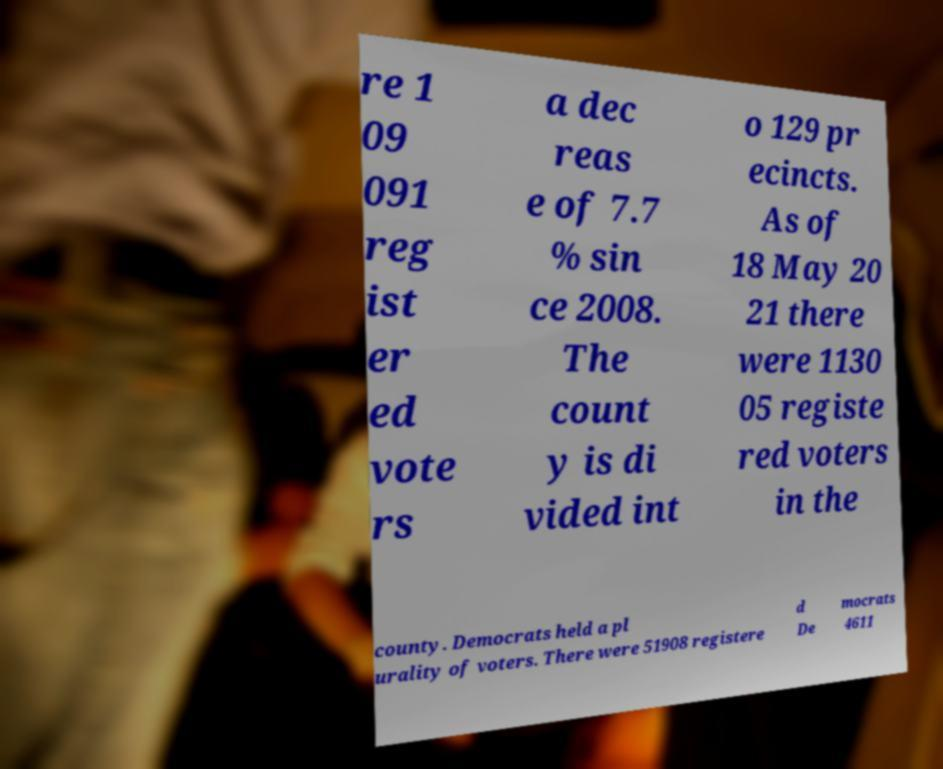Please identify and transcribe the text found in this image. re 1 09 091 reg ist er ed vote rs a dec reas e of 7.7 % sin ce 2008. The count y is di vided int o 129 pr ecincts. As of 18 May 20 21 there were 1130 05 registe red voters in the county. Democrats held a pl urality of voters. There were 51908 registere d De mocrats 4611 